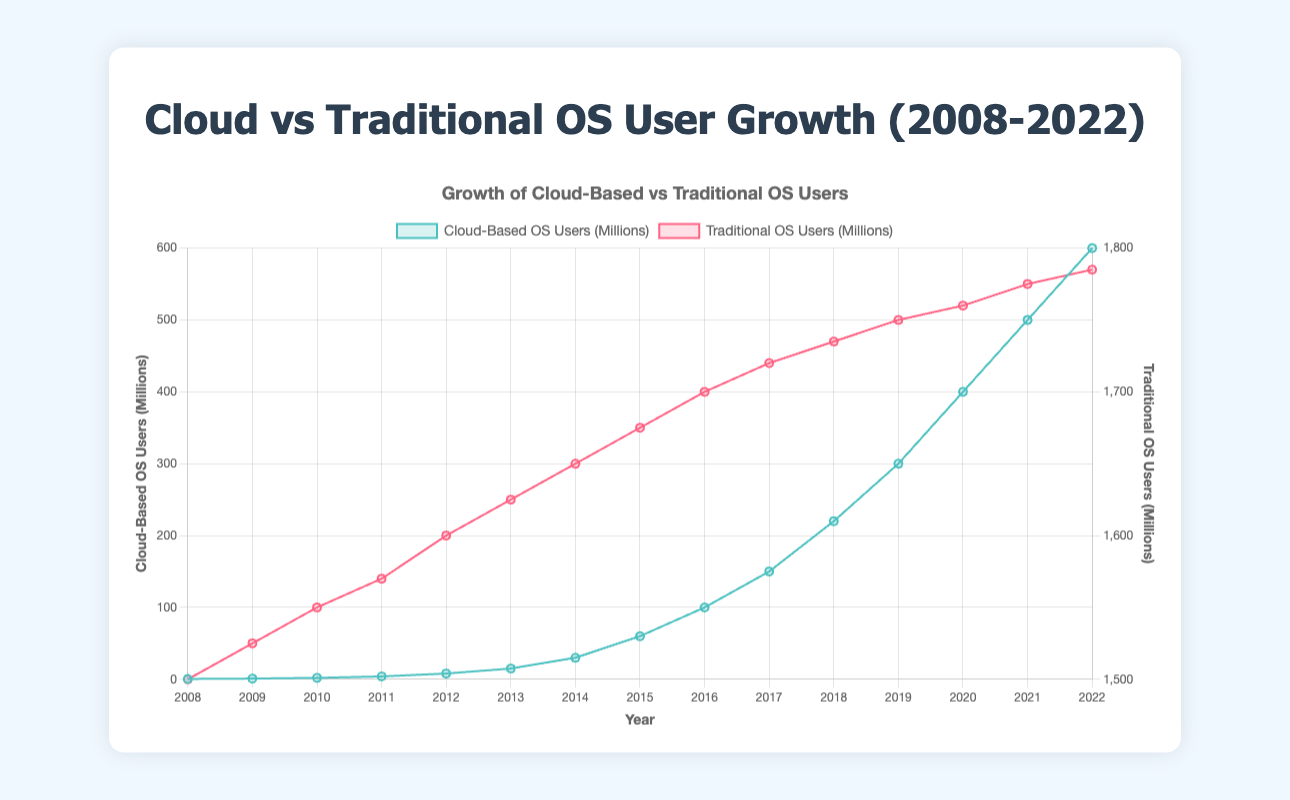What's the overall trend of cloud-based OS users over the years? The trend shows a significant increase in cloud-based OS users from 2008 to 2022, starting from 0.5 million users in 2008 and reaching 600 million users in 2022.
Answer: Rapid increase How does the growth rate of cloud-based OS users compare to traditional OS users? Cloud-based OS users exhibit exponential growth, especially evident from 2014 onwards, while traditional OS users demonstrate a much slower, linear growth.
Answer: Exponential vs Linear In which year did cloud-based OS users first exceed 100 million? In the year 2016, the number of cloud-based OS users reached 100 million.
Answer: 2016 What is the difference in the number of users between traditional and cloud-based OS in 2022? In 2022, traditional OS users were 1785 million, and cloud-based OS users were 600 million. The difference is 1785 - 600 = 1185 million.
Answer: 1185 million Which type of OS had a steadier user growth over the years? Traditional OS users exhibit steadier, linear growth, while cloud-based OS users show more variance with exponential growth.
Answer: Traditional OS When did the number of cloud-based OS users reach 50% of the number of traditional OS users? Cloud-based OS users never reached an equivalent of 50% of traditional OS users during the presented period.
Answer: Never What are the visual differences between the cloud-based and traditional OS lines on the chart? The cloud-based OS line is in blue and shows a sharp upward curve, while the traditional OS line is red and shows a gentle upward slope.
Answer: Different colors and slopes Compare the growth rate of cloud-based OS users from 2015 to 2022. In 2015, there were 60 million cloud-based users, and in 2022, there were 600 million; that's a growth of 540 million in 7 years, averaging around 77 million users per year.
Answer: 77 million/year By how much did the number of traditional OS users increase from 2008 to 2022? Traditional OS users increased from 1500 million in 2008 to 1785 million in 2022, an increase of 285 million.
Answer: 285 million 